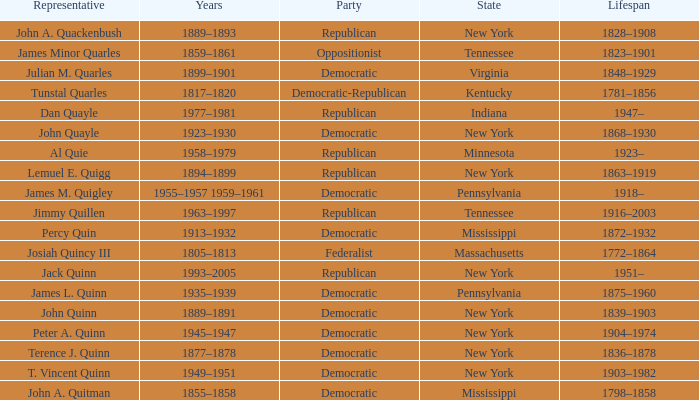What is the lifespan of the democratic party in New York, for which Terence J. Quinn is a representative? 1836–1878. 